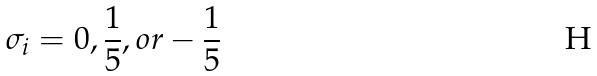<formula> <loc_0><loc_0><loc_500><loc_500>\sigma _ { i } = 0 , \frac { 1 } { 5 } , o r - \frac { 1 } { 5 }</formula> 